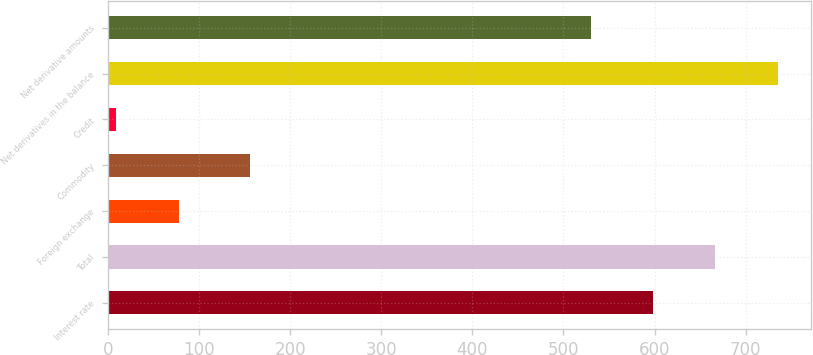Convert chart to OTSL. <chart><loc_0><loc_0><loc_500><loc_500><bar_chart><fcel>Interest rate<fcel>Total<fcel>Foreign exchange<fcel>Commodity<fcel>Credit<fcel>Net derivatives in the balance<fcel>Net derivative amounts<nl><fcel>598.4<fcel>666.8<fcel>77.4<fcel>156<fcel>9<fcel>735.2<fcel>530<nl></chart> 